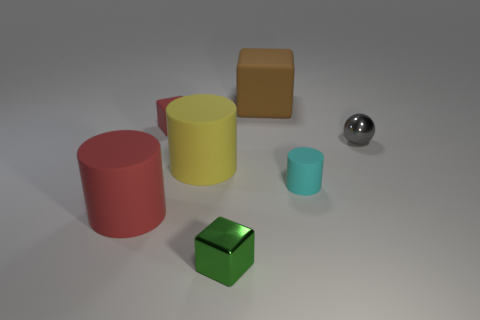There is a big yellow object that is the same material as the red cylinder; what is its shape? cylinder 